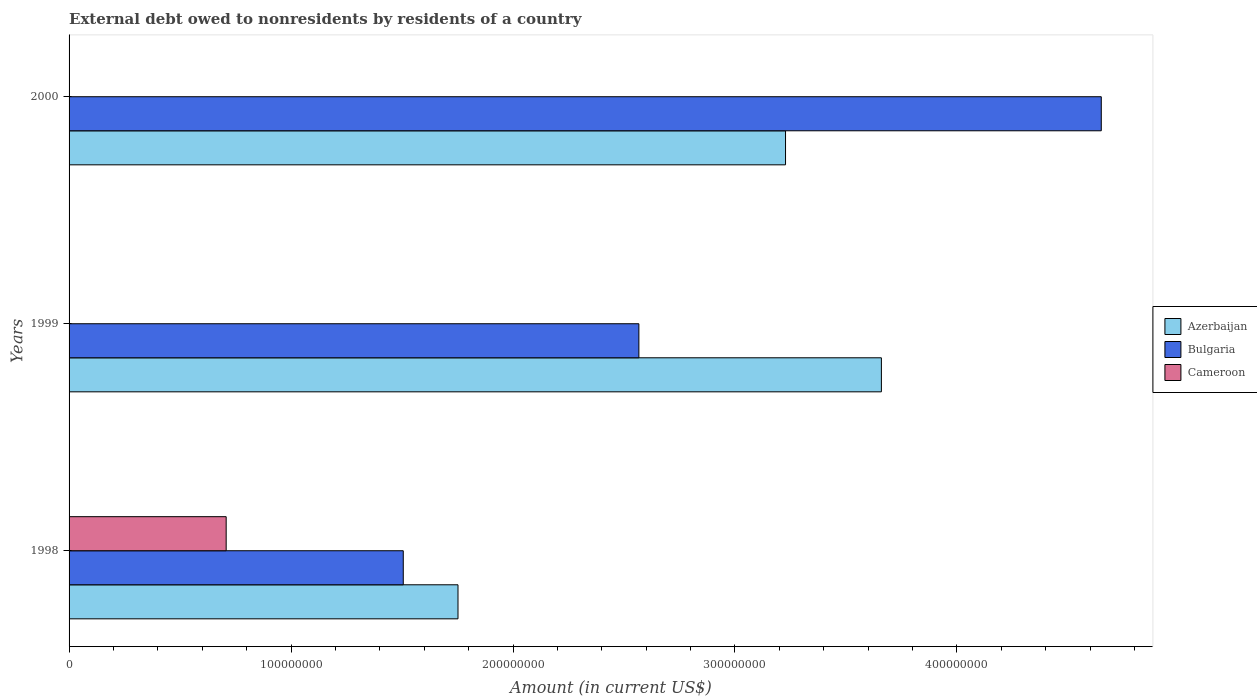How many groups of bars are there?
Give a very brief answer. 3. Are the number of bars on each tick of the Y-axis equal?
Offer a very short reply. No. How many bars are there on the 3rd tick from the top?
Provide a short and direct response. 3. What is the external debt owed by residents in Cameroon in 1998?
Give a very brief answer. 7.08e+07. Across all years, what is the maximum external debt owed by residents in Azerbaijan?
Your answer should be very brief. 3.66e+08. What is the total external debt owed by residents in Bulgaria in the graph?
Ensure brevity in your answer.  8.72e+08. What is the difference between the external debt owed by residents in Bulgaria in 1998 and that in 1999?
Make the answer very short. -1.06e+08. What is the difference between the external debt owed by residents in Azerbaijan in 2000 and the external debt owed by residents in Bulgaria in 1998?
Ensure brevity in your answer.  1.72e+08. What is the average external debt owed by residents in Azerbaijan per year?
Keep it short and to the point. 2.88e+08. In the year 1998, what is the difference between the external debt owed by residents in Azerbaijan and external debt owed by residents in Bulgaria?
Offer a very short reply. 2.47e+07. What is the ratio of the external debt owed by residents in Bulgaria in 1999 to that in 2000?
Give a very brief answer. 0.55. Is the external debt owed by residents in Bulgaria in 1998 less than that in 2000?
Give a very brief answer. Yes. Is the difference between the external debt owed by residents in Azerbaijan in 1998 and 1999 greater than the difference between the external debt owed by residents in Bulgaria in 1998 and 1999?
Provide a short and direct response. No. What is the difference between the highest and the second highest external debt owed by residents in Azerbaijan?
Ensure brevity in your answer.  4.32e+07. What is the difference between the highest and the lowest external debt owed by residents in Azerbaijan?
Provide a succinct answer. 1.91e+08. Is the sum of the external debt owed by residents in Azerbaijan in 1998 and 1999 greater than the maximum external debt owed by residents in Cameroon across all years?
Your response must be concise. Yes. Are all the bars in the graph horizontal?
Provide a succinct answer. Yes. How many years are there in the graph?
Keep it short and to the point. 3. What is the difference between two consecutive major ticks on the X-axis?
Offer a very short reply. 1.00e+08. Are the values on the major ticks of X-axis written in scientific E-notation?
Provide a short and direct response. No. Does the graph contain grids?
Offer a terse response. No. How many legend labels are there?
Offer a very short reply. 3. How are the legend labels stacked?
Make the answer very short. Vertical. What is the title of the graph?
Ensure brevity in your answer.  External debt owed to nonresidents by residents of a country. Does "Cuba" appear as one of the legend labels in the graph?
Your response must be concise. No. What is the Amount (in current US$) of Azerbaijan in 1998?
Offer a terse response. 1.75e+08. What is the Amount (in current US$) of Bulgaria in 1998?
Offer a very short reply. 1.51e+08. What is the Amount (in current US$) in Cameroon in 1998?
Your answer should be compact. 7.08e+07. What is the Amount (in current US$) in Azerbaijan in 1999?
Make the answer very short. 3.66e+08. What is the Amount (in current US$) in Bulgaria in 1999?
Your answer should be compact. 2.57e+08. What is the Amount (in current US$) of Azerbaijan in 2000?
Provide a succinct answer. 3.23e+08. What is the Amount (in current US$) in Bulgaria in 2000?
Provide a succinct answer. 4.65e+08. What is the Amount (in current US$) of Cameroon in 2000?
Your answer should be very brief. 0. Across all years, what is the maximum Amount (in current US$) of Azerbaijan?
Your response must be concise. 3.66e+08. Across all years, what is the maximum Amount (in current US$) in Bulgaria?
Provide a succinct answer. 4.65e+08. Across all years, what is the maximum Amount (in current US$) in Cameroon?
Your answer should be very brief. 7.08e+07. Across all years, what is the minimum Amount (in current US$) in Azerbaijan?
Ensure brevity in your answer.  1.75e+08. Across all years, what is the minimum Amount (in current US$) in Bulgaria?
Provide a short and direct response. 1.51e+08. What is the total Amount (in current US$) in Azerbaijan in the graph?
Offer a very short reply. 8.64e+08. What is the total Amount (in current US$) in Bulgaria in the graph?
Make the answer very short. 8.72e+08. What is the total Amount (in current US$) in Cameroon in the graph?
Provide a succinct answer. 7.08e+07. What is the difference between the Amount (in current US$) in Azerbaijan in 1998 and that in 1999?
Provide a short and direct response. -1.91e+08. What is the difference between the Amount (in current US$) of Bulgaria in 1998 and that in 1999?
Your answer should be compact. -1.06e+08. What is the difference between the Amount (in current US$) in Azerbaijan in 1998 and that in 2000?
Your answer should be very brief. -1.48e+08. What is the difference between the Amount (in current US$) in Bulgaria in 1998 and that in 2000?
Provide a short and direct response. -3.14e+08. What is the difference between the Amount (in current US$) in Azerbaijan in 1999 and that in 2000?
Offer a terse response. 4.32e+07. What is the difference between the Amount (in current US$) of Bulgaria in 1999 and that in 2000?
Your answer should be compact. -2.08e+08. What is the difference between the Amount (in current US$) of Azerbaijan in 1998 and the Amount (in current US$) of Bulgaria in 1999?
Offer a very short reply. -8.15e+07. What is the difference between the Amount (in current US$) of Azerbaijan in 1998 and the Amount (in current US$) of Bulgaria in 2000?
Ensure brevity in your answer.  -2.90e+08. What is the difference between the Amount (in current US$) in Azerbaijan in 1999 and the Amount (in current US$) in Bulgaria in 2000?
Make the answer very short. -9.91e+07. What is the average Amount (in current US$) in Azerbaijan per year?
Keep it short and to the point. 2.88e+08. What is the average Amount (in current US$) of Bulgaria per year?
Your answer should be compact. 2.91e+08. What is the average Amount (in current US$) of Cameroon per year?
Provide a succinct answer. 2.36e+07. In the year 1998, what is the difference between the Amount (in current US$) in Azerbaijan and Amount (in current US$) in Bulgaria?
Keep it short and to the point. 2.47e+07. In the year 1998, what is the difference between the Amount (in current US$) of Azerbaijan and Amount (in current US$) of Cameroon?
Your response must be concise. 1.04e+08. In the year 1998, what is the difference between the Amount (in current US$) in Bulgaria and Amount (in current US$) in Cameroon?
Ensure brevity in your answer.  7.98e+07. In the year 1999, what is the difference between the Amount (in current US$) in Azerbaijan and Amount (in current US$) in Bulgaria?
Keep it short and to the point. 1.09e+08. In the year 2000, what is the difference between the Amount (in current US$) of Azerbaijan and Amount (in current US$) of Bulgaria?
Provide a succinct answer. -1.42e+08. What is the ratio of the Amount (in current US$) in Azerbaijan in 1998 to that in 1999?
Offer a very short reply. 0.48. What is the ratio of the Amount (in current US$) in Bulgaria in 1998 to that in 1999?
Ensure brevity in your answer.  0.59. What is the ratio of the Amount (in current US$) of Azerbaijan in 1998 to that in 2000?
Provide a succinct answer. 0.54. What is the ratio of the Amount (in current US$) in Bulgaria in 1998 to that in 2000?
Keep it short and to the point. 0.32. What is the ratio of the Amount (in current US$) in Azerbaijan in 1999 to that in 2000?
Provide a succinct answer. 1.13. What is the ratio of the Amount (in current US$) in Bulgaria in 1999 to that in 2000?
Provide a succinct answer. 0.55. What is the difference between the highest and the second highest Amount (in current US$) in Azerbaijan?
Your answer should be very brief. 4.32e+07. What is the difference between the highest and the second highest Amount (in current US$) of Bulgaria?
Your answer should be very brief. 2.08e+08. What is the difference between the highest and the lowest Amount (in current US$) of Azerbaijan?
Provide a succinct answer. 1.91e+08. What is the difference between the highest and the lowest Amount (in current US$) of Bulgaria?
Your answer should be very brief. 3.14e+08. What is the difference between the highest and the lowest Amount (in current US$) of Cameroon?
Provide a succinct answer. 7.08e+07. 